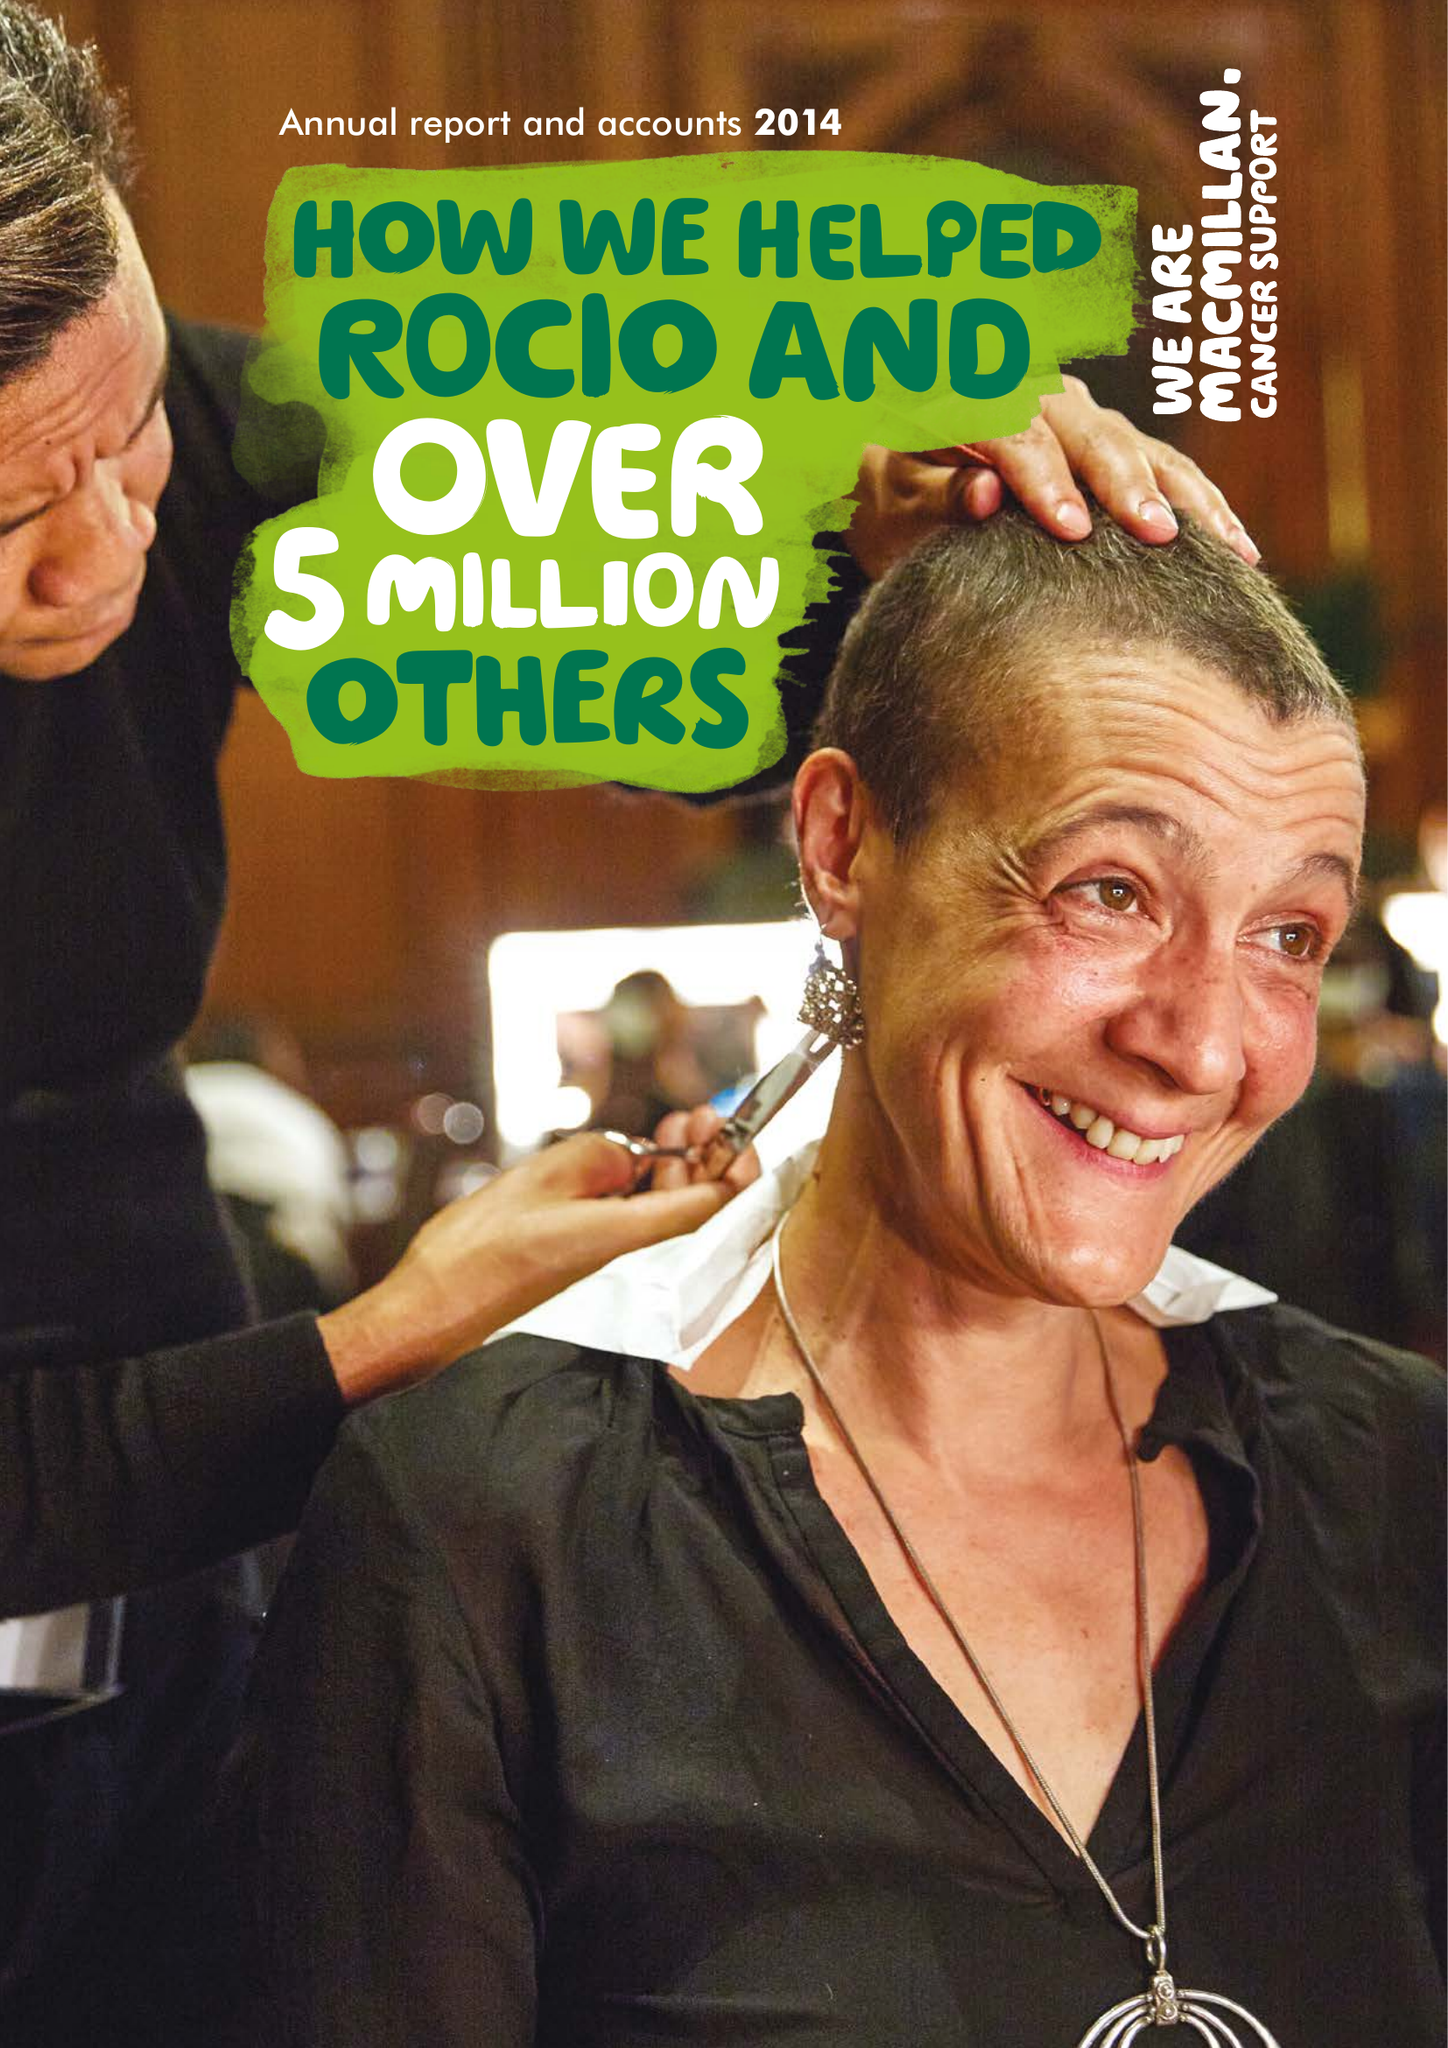What is the value for the charity_name?
Answer the question using a single word or phrase. Macmillan Cancer Support 